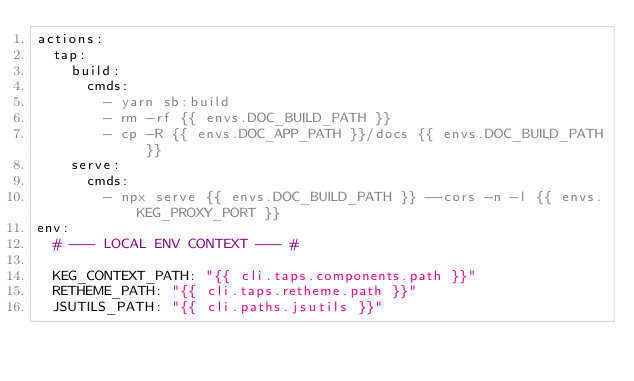Convert code to text. <code><loc_0><loc_0><loc_500><loc_500><_YAML_>actions:
  tap:
    build:
      cmds:
        - yarn sb:build
        - rm -rf {{ envs.DOC_BUILD_PATH }}
        - cp -R {{ envs.DOC_APP_PATH }}/docs {{ envs.DOC_BUILD_PATH }}
    serve:
      cmds:
        - npx serve {{ envs.DOC_BUILD_PATH }} --cors -n -l {{ envs.KEG_PROXY_PORT }}
env:
  # --- LOCAL ENV CONTEXT --- #

  KEG_CONTEXT_PATH: "{{ cli.taps.components.path }}"
  RETHEME_PATH: "{{ cli.taps.retheme.path }}"
  JSUTILS_PATH: "{{ cli.paths.jsutils }}"
</code> 